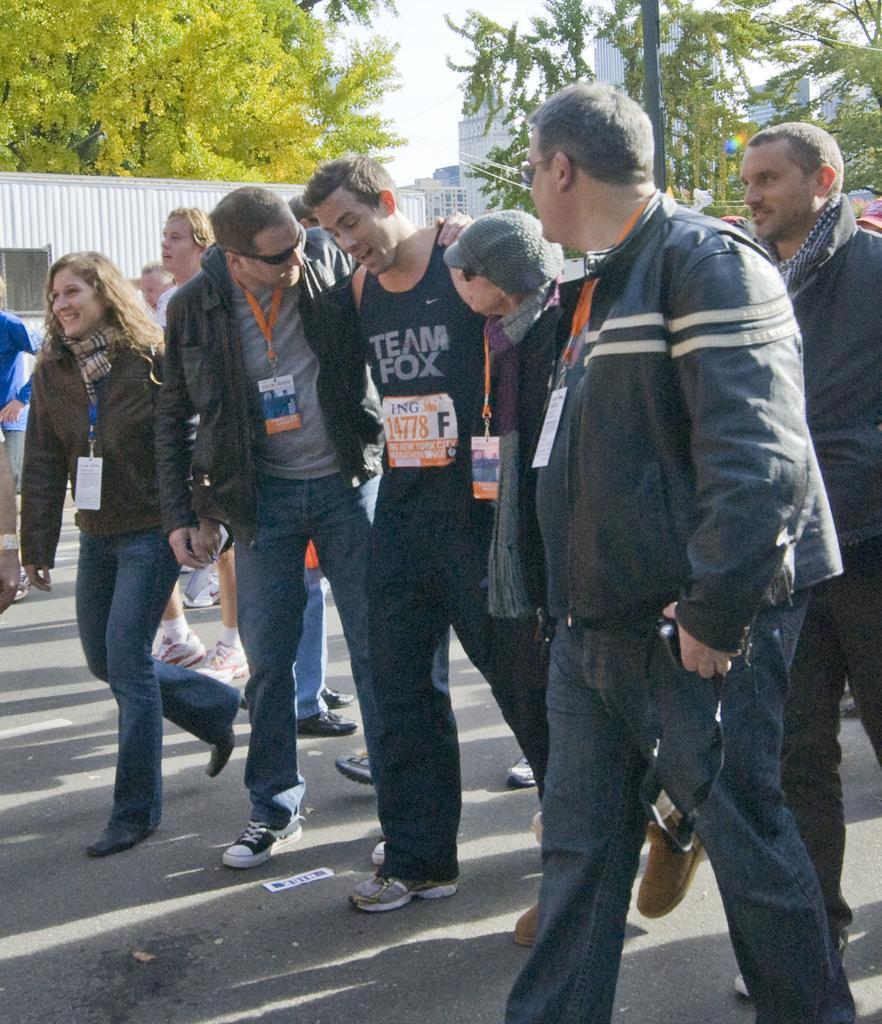Please provide a concise description of this image. In this image we can see people walking on the road. In the background there are poles, buildings, trees and sky. 